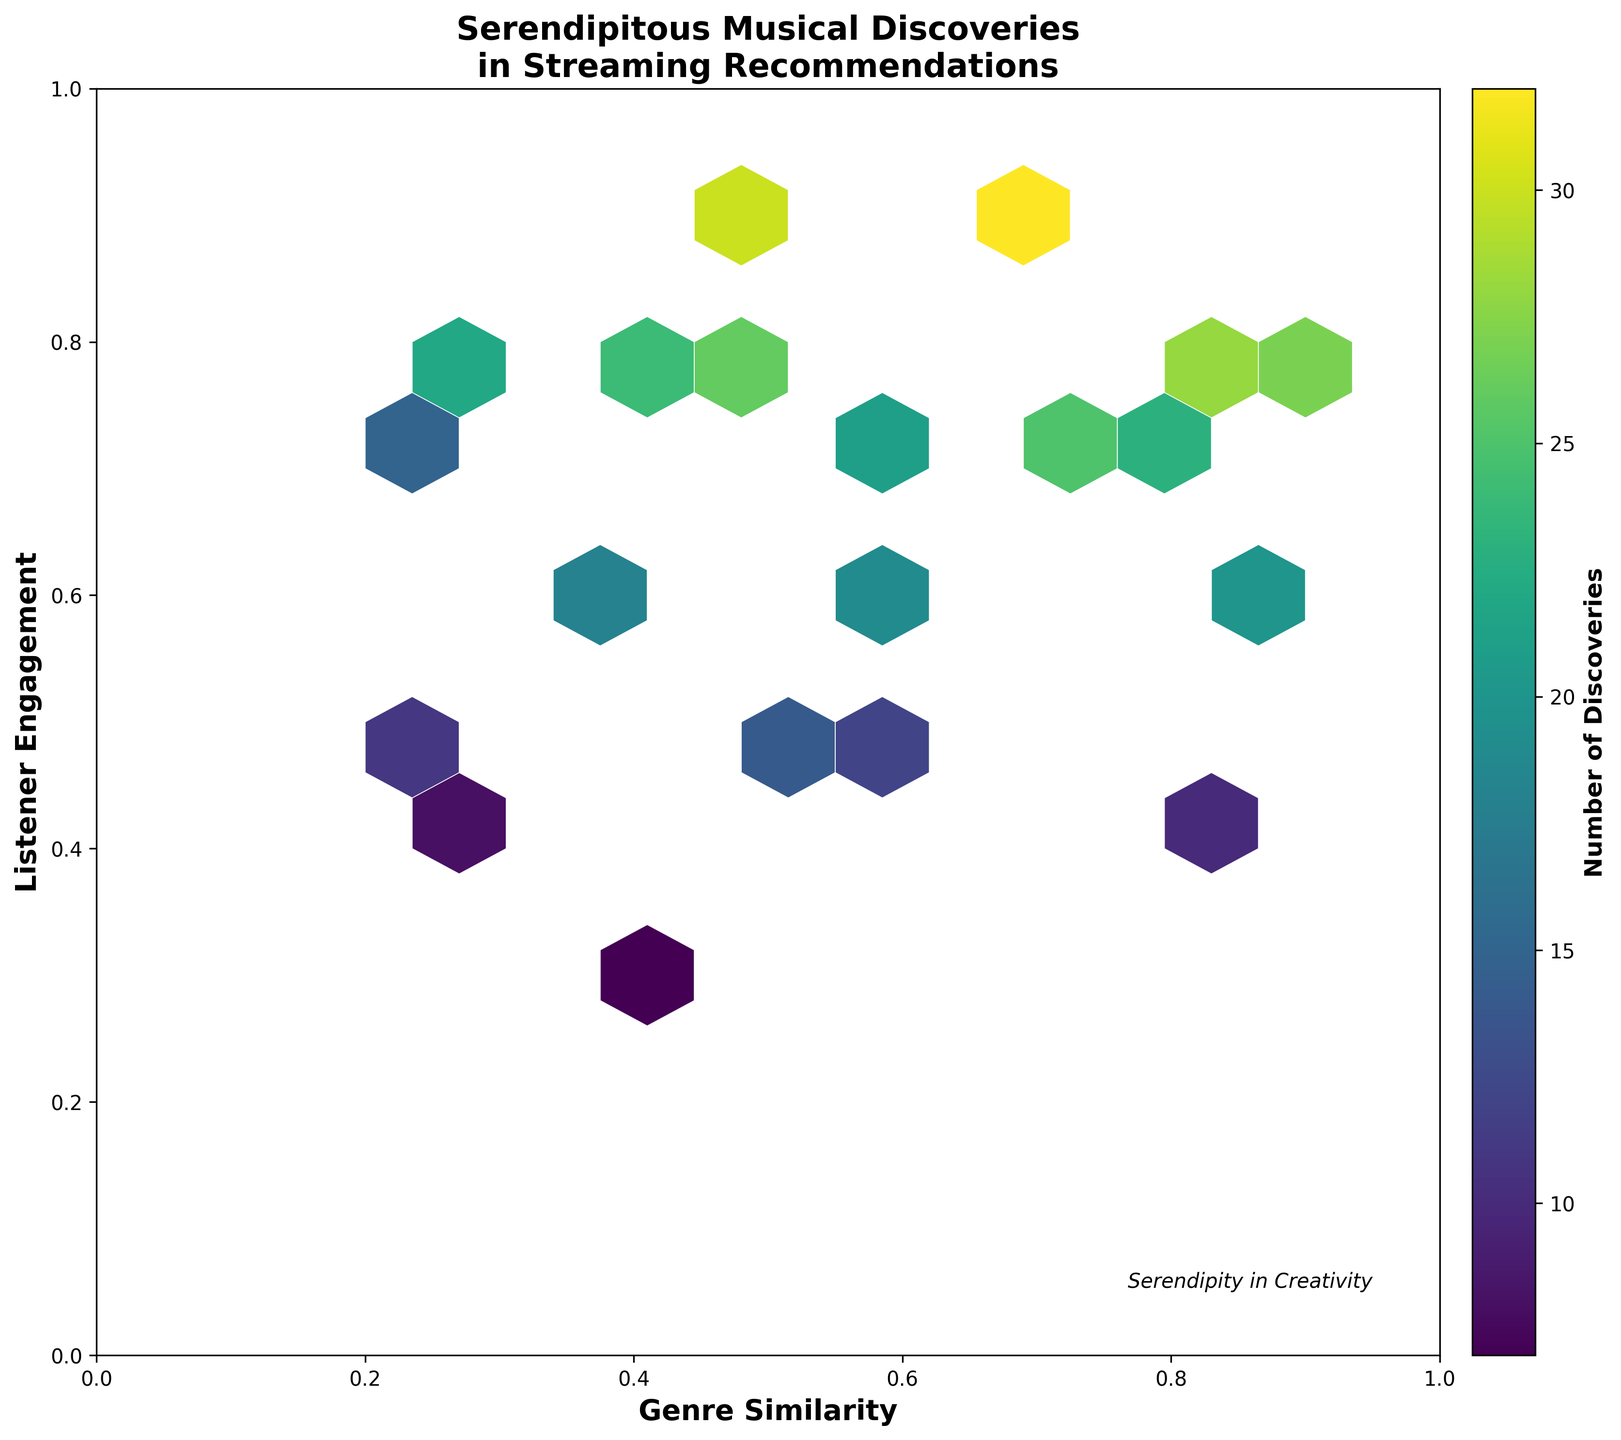What is the x-axis label? The hexbin plot has an x-axis label which represents the variable plotted along that axis. According to the plot's data context, we can determine by looking at the chart that the x-axis label is 'Genre Similarity'.
Answer: Genre Similarity What does the color in the hexbin plot represent? Colors in a hexbin plot often indicate the density or count of observations within each hexagonal bin. By referring to the color bar, we see it represents 'Number of Discoveries', mapped according to density.
Answer: Number of Discoveries What is the relationship between genre similarity and listener engagement at high discovery counts? To understand the relationship, observe the locations of hexagons with darker colors (indicating higher discovery counts). These hexagons are mostly found in areas where both genre similarity and listener engagement are high.
Answer: Higher genre similarity and higher listener engagement Which bin has the highest number of musical discoveries? To find the bin with the highest discovery count, look for the darkest hexagon in the plot, because darker colors indicate higher counts. The darkest hexagon is in the area around genre similarity of 0.7 and listener engagement of 0.9.
Answer: Genre similarity 0.7 and listener engagement 0.9 How many bins are displayed in the plot? The total number of bins is determined by the grid size used in the plot creation. Counting the hexagonal bins visually, there are about 10 x 10 bins, as specified to create a grid of this size.
Answer: About 100 bins Which has more musical discoveries: bins with a genre similarity of around 0.5 or bins with a genre similarity of around 0.8? To compare, we observe regions where genre similarity is around 0.5 and 0.8. Bins around 0.8 generally show darker colors compared to those around 0.5, indicating they have more musical discoveries.
Answer: Genre similarity of around 0.8 Within regions of genre similarity between 0.3 to 0.6, which range of listener engagement shows the most discoveries? To find this, observe bins for genre similarity from 0.3 to 0.6 and compare listener engagement levels. The bins around listener engagement of 0.7 and 0.8, with genre similarity values within this range, are darker.
Answer: Listener engagement of around 0.7 and 0.8 Is there a positive correlation between genre similarity and the number of discoveries? A positive correlation would show that higher genre similarity is associated with higher discovery counts. Observing the hexagon colors, regions with higher genre similarity tend to have darker shades, indicating more discoveries.
Answer: Yes Which engagement level has fewer discoveries for genre similarity of 0.8, 0.4 or 0.7? Compare the bins at genre similarity of 0.8 for listener engagements 0.4 and 0.7. The hexagon at 0.8 genre similarity and 0.4 engagement is lighter compared to the hexagon at 0.8 genre similarity and 0.7 engagement, indicating fewer discoveries.
Answer: Listener engagement of 0.4 